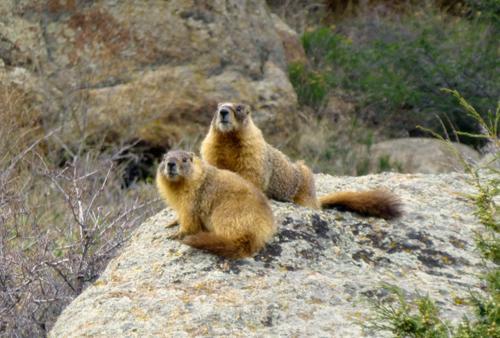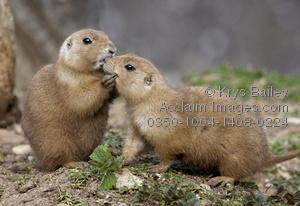The first image is the image on the left, the second image is the image on the right. Given the left and right images, does the statement "Two animals in the image in the left are sitting face to face." hold true? Answer yes or no. No. The first image is the image on the left, the second image is the image on the right. Assess this claim about the two images: "One of the images shows two groundhogs facing each other.". Correct or not? Answer yes or no. Yes. 